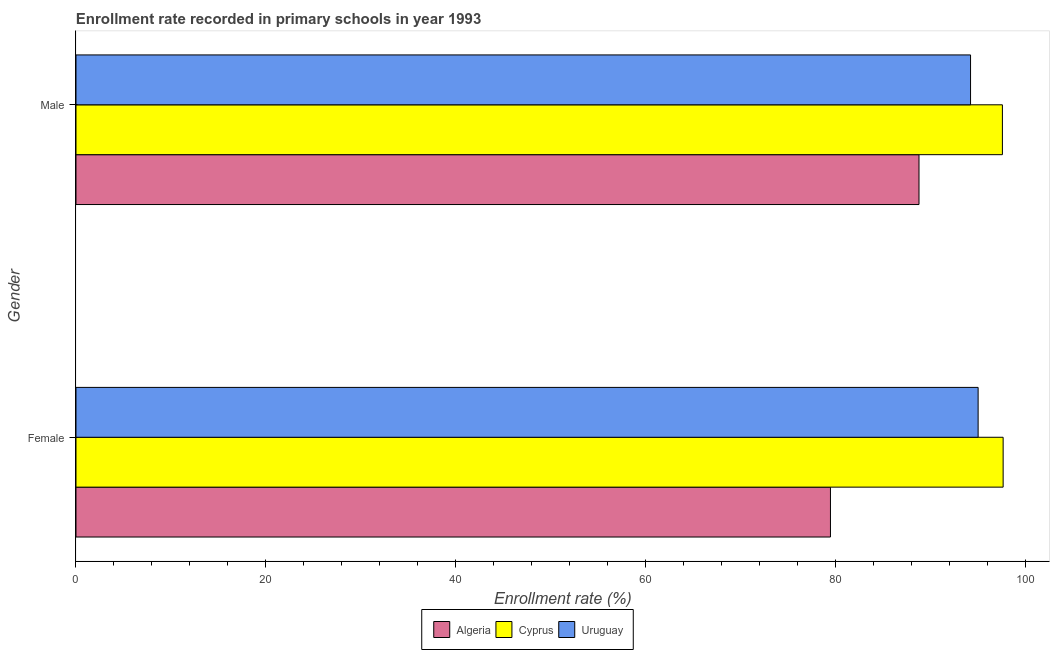How many different coloured bars are there?
Your response must be concise. 3. Are the number of bars per tick equal to the number of legend labels?
Your response must be concise. Yes. Are the number of bars on each tick of the Y-axis equal?
Your answer should be compact. Yes. How many bars are there on the 1st tick from the top?
Give a very brief answer. 3. How many bars are there on the 1st tick from the bottom?
Your response must be concise. 3. What is the label of the 2nd group of bars from the top?
Make the answer very short. Female. What is the enrollment rate of female students in Cyprus?
Offer a terse response. 97.67. Across all countries, what is the maximum enrollment rate of female students?
Provide a short and direct response. 97.67. Across all countries, what is the minimum enrollment rate of male students?
Offer a terse response. 88.81. In which country was the enrollment rate of female students maximum?
Offer a very short reply. Cyprus. In which country was the enrollment rate of female students minimum?
Keep it short and to the point. Algeria. What is the total enrollment rate of male students in the graph?
Provide a succinct answer. 280.63. What is the difference between the enrollment rate of male students in Cyprus and that in Algeria?
Provide a short and direct response. 8.79. What is the difference between the enrollment rate of female students in Algeria and the enrollment rate of male students in Cyprus?
Make the answer very short. -18.12. What is the average enrollment rate of female students per country?
Offer a terse response. 90.73. What is the difference between the enrollment rate of female students and enrollment rate of male students in Cyprus?
Ensure brevity in your answer.  0.08. In how many countries, is the enrollment rate of female students greater than 32 %?
Give a very brief answer. 3. What is the ratio of the enrollment rate of female students in Uruguay to that in Algeria?
Give a very brief answer. 1.2. Is the enrollment rate of female students in Uruguay less than that in Algeria?
Offer a very short reply. No. What does the 3rd bar from the top in Male represents?
Make the answer very short. Algeria. What does the 2nd bar from the bottom in Male represents?
Provide a short and direct response. Cyprus. Are all the bars in the graph horizontal?
Give a very brief answer. Yes. Are the values on the major ticks of X-axis written in scientific E-notation?
Your response must be concise. No. Where does the legend appear in the graph?
Offer a terse response. Bottom center. How are the legend labels stacked?
Provide a short and direct response. Horizontal. What is the title of the graph?
Give a very brief answer. Enrollment rate recorded in primary schools in year 1993. Does "Guyana" appear as one of the legend labels in the graph?
Provide a succinct answer. No. What is the label or title of the X-axis?
Make the answer very short. Enrollment rate (%). What is the label or title of the Y-axis?
Give a very brief answer. Gender. What is the Enrollment rate (%) of Algeria in Female?
Keep it short and to the point. 79.48. What is the Enrollment rate (%) of Cyprus in Female?
Offer a terse response. 97.67. What is the Enrollment rate (%) in Uruguay in Female?
Offer a terse response. 95.03. What is the Enrollment rate (%) of Algeria in Male?
Make the answer very short. 88.81. What is the Enrollment rate (%) of Cyprus in Male?
Ensure brevity in your answer.  97.59. What is the Enrollment rate (%) of Uruguay in Male?
Offer a very short reply. 94.24. Across all Gender, what is the maximum Enrollment rate (%) of Algeria?
Make the answer very short. 88.81. Across all Gender, what is the maximum Enrollment rate (%) of Cyprus?
Provide a succinct answer. 97.67. Across all Gender, what is the maximum Enrollment rate (%) in Uruguay?
Make the answer very short. 95.03. Across all Gender, what is the minimum Enrollment rate (%) of Algeria?
Your answer should be very brief. 79.48. Across all Gender, what is the minimum Enrollment rate (%) of Cyprus?
Offer a terse response. 97.59. Across all Gender, what is the minimum Enrollment rate (%) of Uruguay?
Keep it short and to the point. 94.24. What is the total Enrollment rate (%) in Algeria in the graph?
Ensure brevity in your answer.  168.28. What is the total Enrollment rate (%) of Cyprus in the graph?
Offer a terse response. 195.26. What is the total Enrollment rate (%) of Uruguay in the graph?
Provide a short and direct response. 189.27. What is the difference between the Enrollment rate (%) in Algeria in Female and that in Male?
Your answer should be very brief. -9.33. What is the difference between the Enrollment rate (%) in Cyprus in Female and that in Male?
Provide a short and direct response. 0.08. What is the difference between the Enrollment rate (%) in Uruguay in Female and that in Male?
Your answer should be very brief. 0.8. What is the difference between the Enrollment rate (%) of Algeria in Female and the Enrollment rate (%) of Cyprus in Male?
Provide a succinct answer. -18.12. What is the difference between the Enrollment rate (%) of Algeria in Female and the Enrollment rate (%) of Uruguay in Male?
Offer a terse response. -14.76. What is the difference between the Enrollment rate (%) of Cyprus in Female and the Enrollment rate (%) of Uruguay in Male?
Ensure brevity in your answer.  3.43. What is the average Enrollment rate (%) in Algeria per Gender?
Your answer should be very brief. 84.14. What is the average Enrollment rate (%) of Cyprus per Gender?
Your answer should be very brief. 97.63. What is the average Enrollment rate (%) of Uruguay per Gender?
Provide a short and direct response. 94.64. What is the difference between the Enrollment rate (%) of Algeria and Enrollment rate (%) of Cyprus in Female?
Keep it short and to the point. -18.19. What is the difference between the Enrollment rate (%) in Algeria and Enrollment rate (%) in Uruguay in Female?
Offer a terse response. -15.56. What is the difference between the Enrollment rate (%) in Cyprus and Enrollment rate (%) in Uruguay in Female?
Offer a very short reply. 2.63. What is the difference between the Enrollment rate (%) in Algeria and Enrollment rate (%) in Cyprus in Male?
Provide a short and direct response. -8.79. What is the difference between the Enrollment rate (%) in Algeria and Enrollment rate (%) in Uruguay in Male?
Your response must be concise. -5.43. What is the difference between the Enrollment rate (%) in Cyprus and Enrollment rate (%) in Uruguay in Male?
Keep it short and to the point. 3.36. What is the ratio of the Enrollment rate (%) in Algeria in Female to that in Male?
Make the answer very short. 0.9. What is the ratio of the Enrollment rate (%) in Cyprus in Female to that in Male?
Your answer should be compact. 1. What is the ratio of the Enrollment rate (%) of Uruguay in Female to that in Male?
Your response must be concise. 1.01. What is the difference between the highest and the second highest Enrollment rate (%) of Algeria?
Provide a succinct answer. 9.33. What is the difference between the highest and the second highest Enrollment rate (%) in Cyprus?
Keep it short and to the point. 0.08. What is the difference between the highest and the second highest Enrollment rate (%) of Uruguay?
Your answer should be compact. 0.8. What is the difference between the highest and the lowest Enrollment rate (%) in Algeria?
Offer a very short reply. 9.33. What is the difference between the highest and the lowest Enrollment rate (%) of Cyprus?
Provide a succinct answer. 0.08. What is the difference between the highest and the lowest Enrollment rate (%) of Uruguay?
Your answer should be compact. 0.8. 